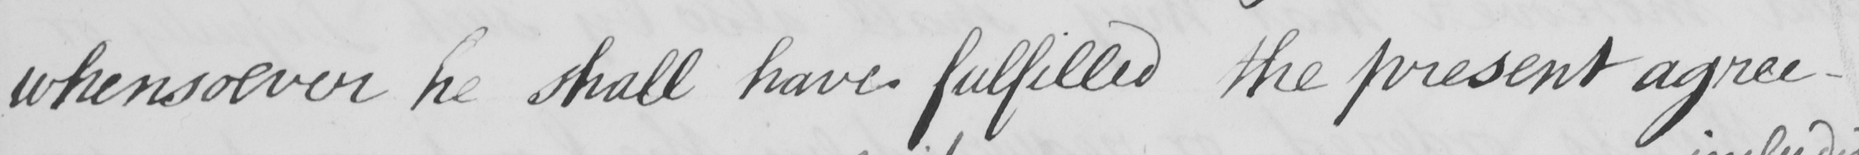What is written in this line of handwriting? whensoever he shall have fulfilled the present agree- 